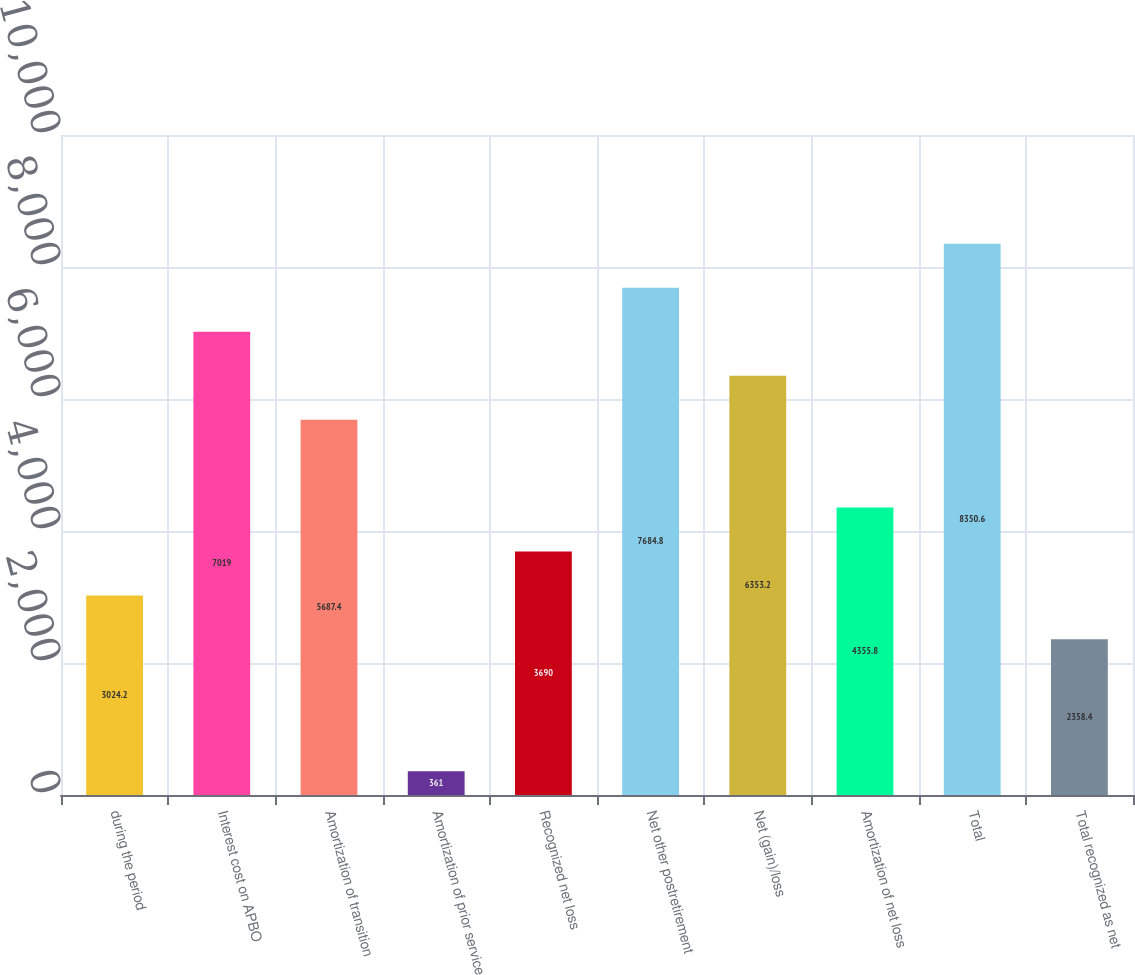<chart> <loc_0><loc_0><loc_500><loc_500><bar_chart><fcel>during the period<fcel>Interest cost on APBO<fcel>Amortization of transition<fcel>Amortization of prior service<fcel>Recognized net loss<fcel>Net other postretirement<fcel>Net (gain)/loss<fcel>Amortization of net loss<fcel>Total<fcel>Total recognized as net<nl><fcel>3024.2<fcel>7019<fcel>5687.4<fcel>361<fcel>3690<fcel>7684.8<fcel>6353.2<fcel>4355.8<fcel>8350.6<fcel>2358.4<nl></chart> 